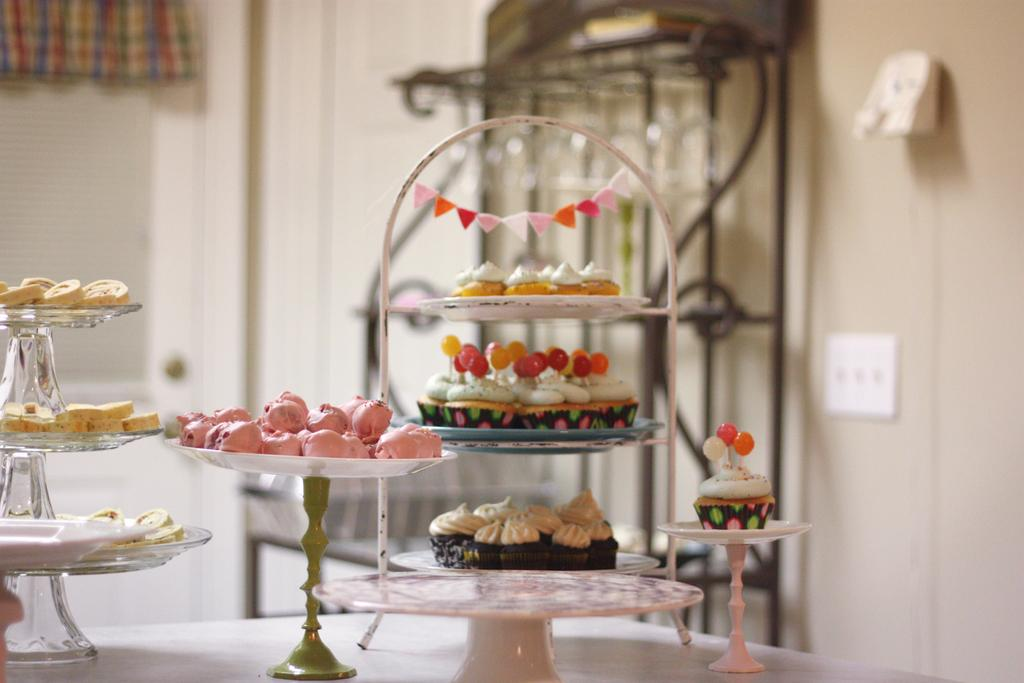What types of treats are visible in the image? There are cookies, candies, and muffins in the image. How are the treats arranged in the image? The treats are placed on different stands. Where are the stands located? The stands are on a table. Can you describe the stand on the backside of the image? There is a stand on the backside of the image, but no specific details about it are provided. What else can be seen in the image besides the treats and stands? There is a switch board on a wall in the image. What type of string is used to hang the cookies in the image? There is no string visible in the image; the cookies are placed on stands. 